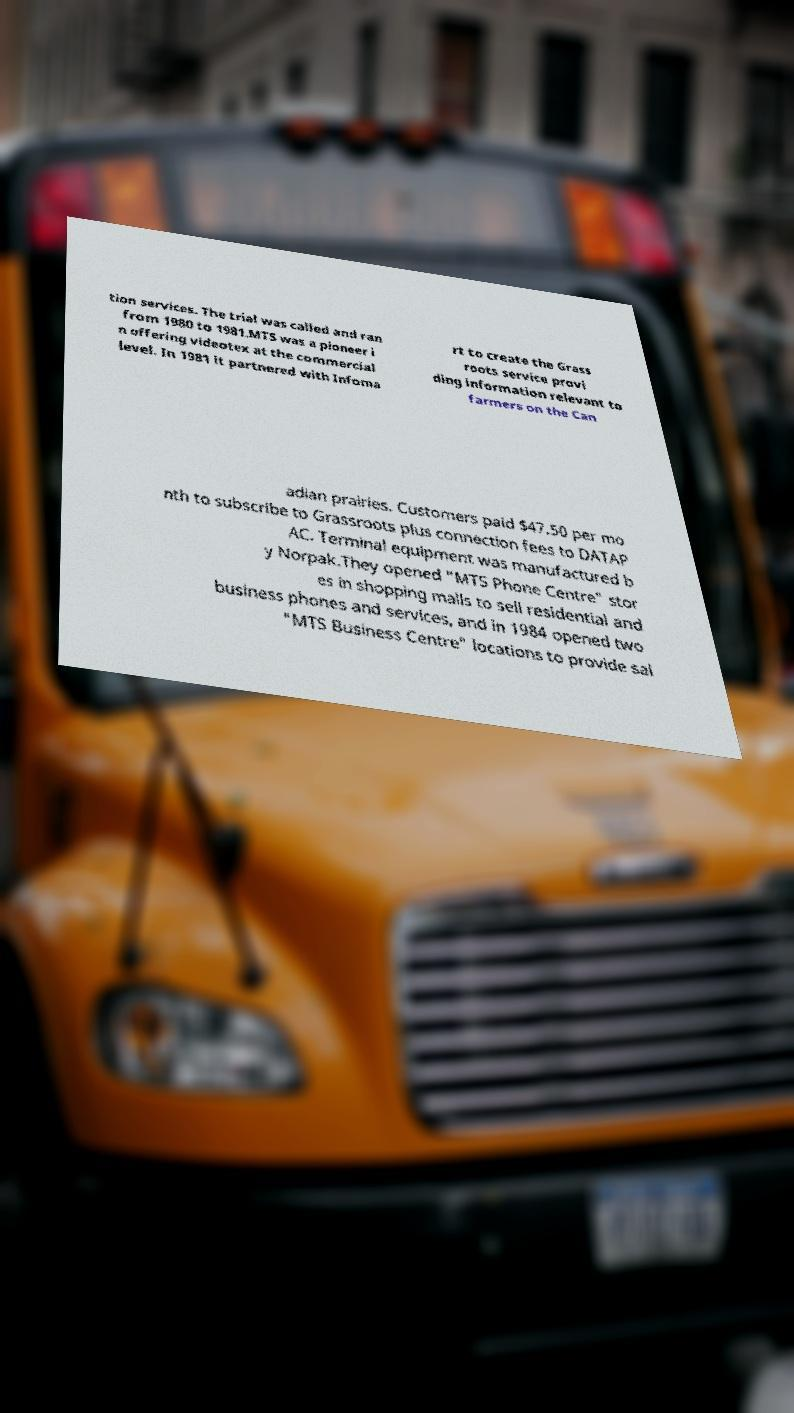I need the written content from this picture converted into text. Can you do that? tion services. The trial was called and ran from 1980 to 1981.MTS was a pioneer i n offering videotex at the commercial level. In 1981 it partnered with Infoma rt to create the Grass roots service provi ding information relevant to farmers on the Can adian prairies. Customers paid $47.50 per mo nth to subscribe to Grassroots plus connection fees to DATAP AC. Terminal equipment was manufactured b y Norpak.They opened "MTS Phone Centre" stor es in shopping malls to sell residential and business phones and services, and in 1984 opened two "MTS Business Centre" locations to provide sal 